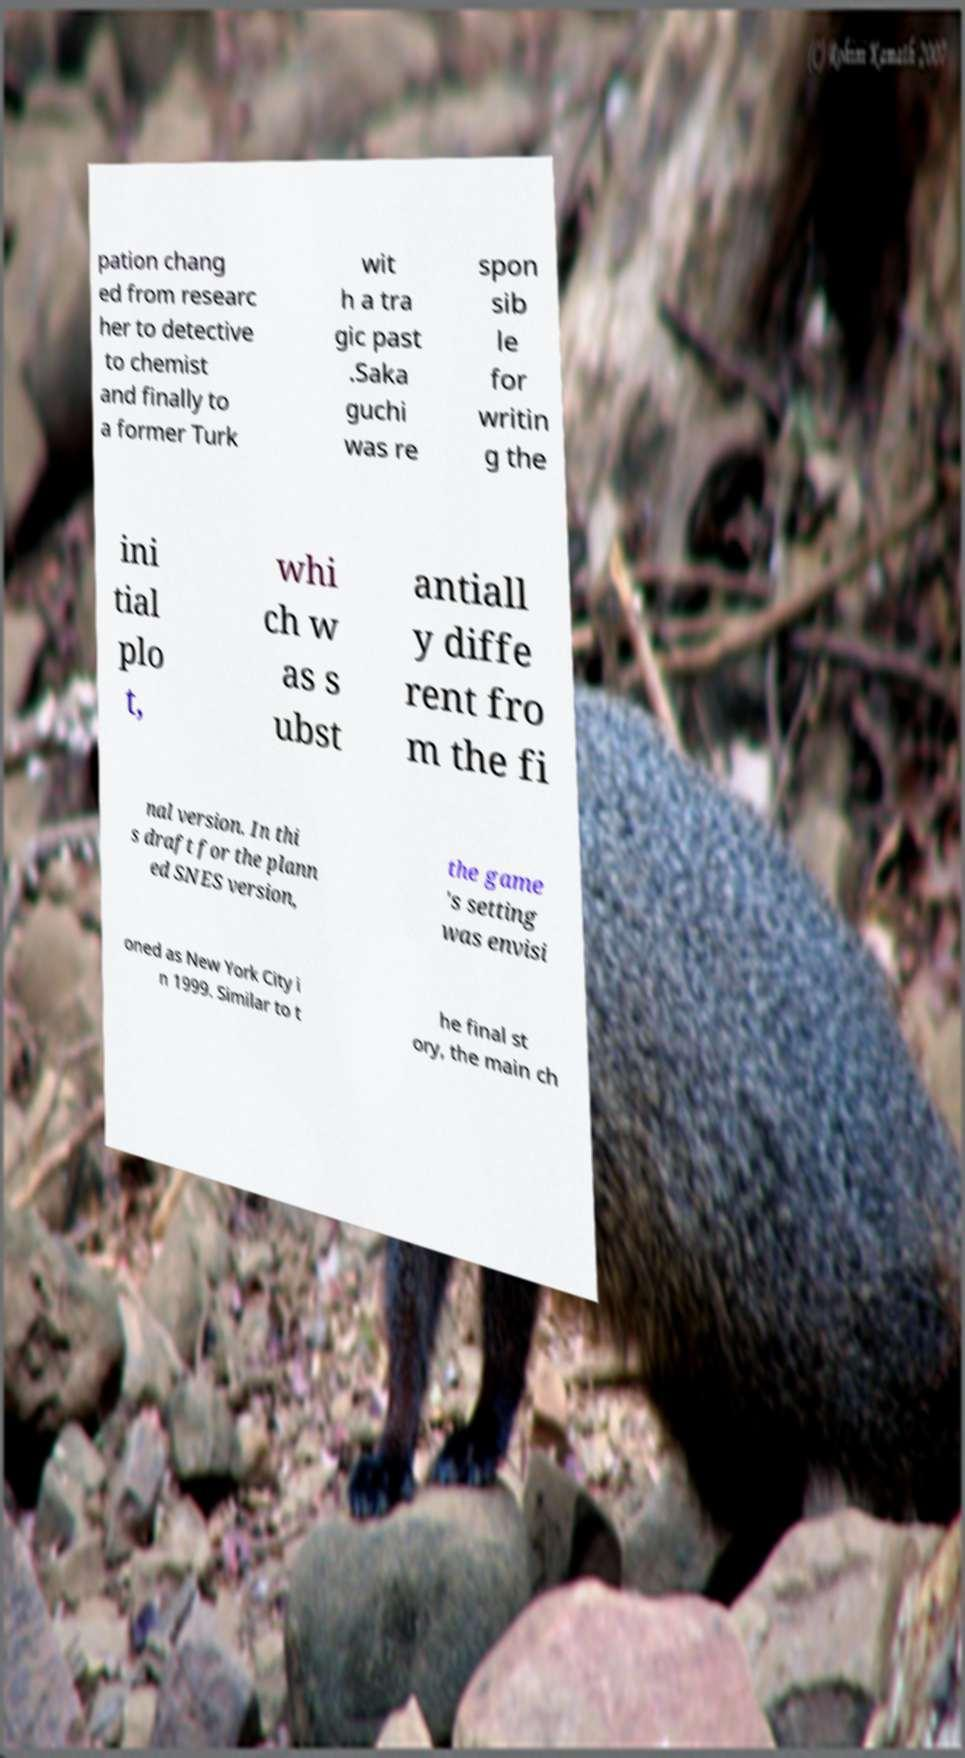There's text embedded in this image that I need extracted. Can you transcribe it verbatim? pation chang ed from researc her to detective to chemist and finally to a former Turk wit h a tra gic past .Saka guchi was re spon sib le for writin g the ini tial plo t, whi ch w as s ubst antiall y diffe rent fro m the fi nal version. In thi s draft for the plann ed SNES version, the game 's setting was envisi oned as New York City i n 1999. Similar to t he final st ory, the main ch 